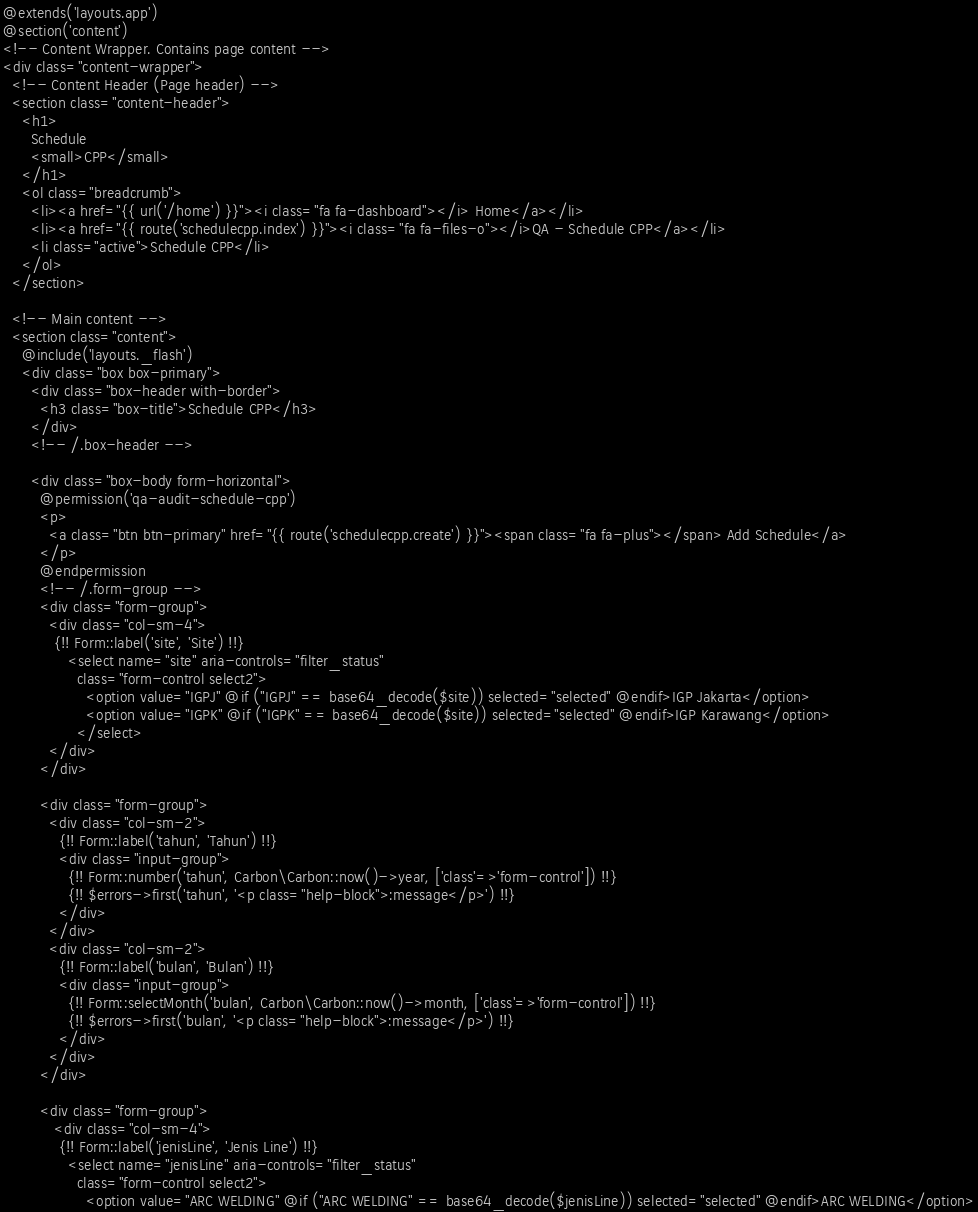Convert code to text. <code><loc_0><loc_0><loc_500><loc_500><_PHP_>@extends('layouts.app')
@section('content')
<!-- Content Wrapper. Contains page content -->
<div class="content-wrapper">
  <!-- Content Header (Page header) -->
  <section class="content-header">
    <h1>
      Schedule 
      <small>CPP</small>
    </h1>
    <ol class="breadcrumb">
      <li><a href="{{ url('/home') }}"><i class="fa fa-dashboard"></i> Home</a></li>
      <li><a href="{{ route('schedulecpp.index') }}"><i class="fa fa-files-o"></i>QA - Schedule CPP</a></li>
      <li class="active">Schedule CPP</li> 
    </ol>
  </section>

  <!-- Main content -->
  <section class="content">
    @include('layouts._flash')
    <div class="box box-primary">
      <div class="box-header with-border">
        <h3 class="box-title">Schedule CPP</h3>
      </div>
      <!-- /.box-header -->
      
      <div class="box-body form-horizontal"> 
        @permission('qa-audit-schedule-cpp')
        <p>
          <a class="btn btn-primary" href="{{ route('schedulecpp.create') }}"><span class="fa fa-plus"></span> Add Schedule</a>
        </p>
        @endpermission        
        <!-- /.form-group -->
        <div class="form-group">
          <div class="col-sm-4">
           {!! Form::label('site', 'Site') !!}
              <select name="site" aria-controls="filter_status" 
                class="form-control select2">
                  <option value="IGPJ" @if ("IGPJ" == base64_decode($site)) selected="selected" @endif>IGP Jakarta</option>
                  <option value="IGPK" @if ("IGPK" == base64_decode($site)) selected="selected" @endif>IGP Karawang</option>
                </select>
          </div>         
        </div>

        <div class="form-group">
          <div class="col-sm-2">
            {!! Form::label('tahun', 'Tahun') !!}
            <div class="input-group">
              {!! Form::number('tahun', Carbon\Carbon::now()->year, ['class'=>'form-control']) !!}
              {!! $errors->first('tahun', '<p class="help-block">:message</p>') !!}
            </div>
          </div>
          <div class="col-sm-2">
            {!! Form::label('bulan', 'Bulan') !!}
            <div class="input-group">
              {!! Form::selectMonth('bulan', Carbon\Carbon::now()->month, ['class'=>'form-control']) !!}
              {!! $errors->first('bulan', '<p class="help-block">:message</p>') !!}       
            </div>            
          </div>
        </div>

        <div class="form-group">
           <div class="col-sm-4">
            {!! Form::label('jenisLine', 'Jenis Line') !!}
              <select name="jenisLine" aria-controls="filter_status" 
                class="form-control select2">
                  <option value="ARC WELDING" @if ("ARC WELDING" == base64_decode($jenisLine)) selected="selected" @endif>ARC WELDING</option></code> 